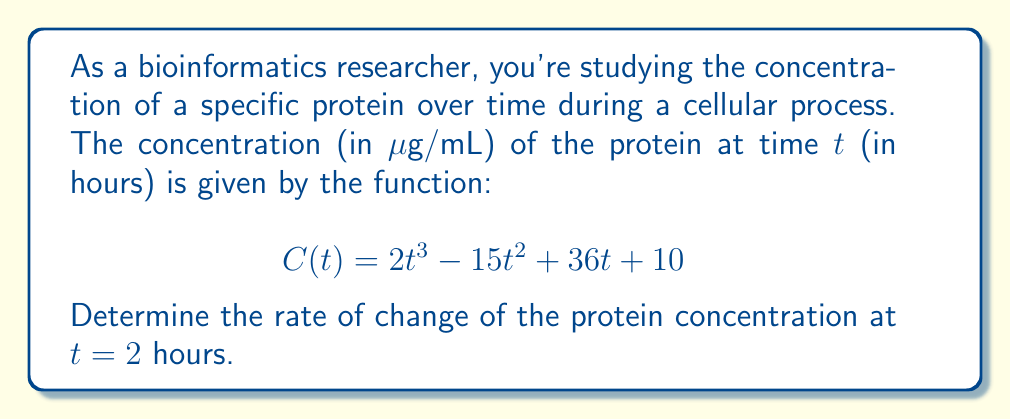Can you solve this math problem? To solve this problem, we need to follow these steps:

1. Understand that the rate of change of the protein concentration is represented by the derivative of the concentration function C(t).

2. Find the derivative of C(t):
   $$\frac{d}{dt}C(t) = \frac{d}{dt}(2t^3 - 15t^2 + 36t + 10)$$
   $$C'(t) = 6t^2 - 30t + 36$$

3. Evaluate the derivative at t = 2:
   $$C'(2) = 6(2)^2 - 30(2) + 36$$
   $$C'(2) = 6(4) - 60 + 36$$
   $$C'(2) = 24 - 60 + 36$$
   $$C'(2) = 0$$

The rate of change at t = 2 hours is 0 μg/mL per hour. This means that at exactly 2 hours, the protein concentration is neither increasing nor decreasing.

In the context of bioinformatics, this could indicate a point of equilibrium or a transition point in the cellular process you're studying. It might be worth investigating what biological events occur around this time point that could explain this momentary stabilization of the protein concentration.
Answer: The rate of change of the protein concentration at t = 2 hours is 0 μg/mL per hour. 